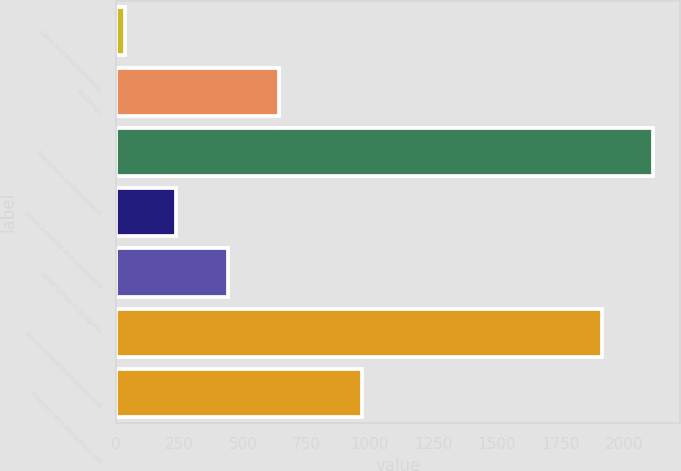<chart> <loc_0><loc_0><loc_500><loc_500><bar_chart><fcel>Land and improvements<fcel>Buildings<fcel>Machinery andequipment<fcel>Other property and equipment<fcel>Construction-in-progress<fcel>Accumulateddepreciation and<fcel>Property and equipment net<nl><fcel>35.7<fcel>641.25<fcel>2113.35<fcel>237.55<fcel>439.4<fcel>1911.5<fcel>970.1<nl></chart> 